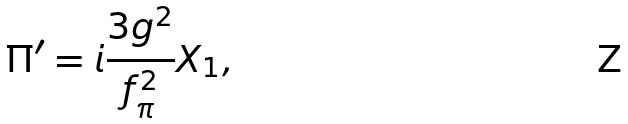<formula> <loc_0><loc_0><loc_500><loc_500>\Pi ^ { \prime } = i \frac { 3 g ^ { 2 } } { f _ { \pi } ^ { 2 } } X _ { 1 } ,</formula> 